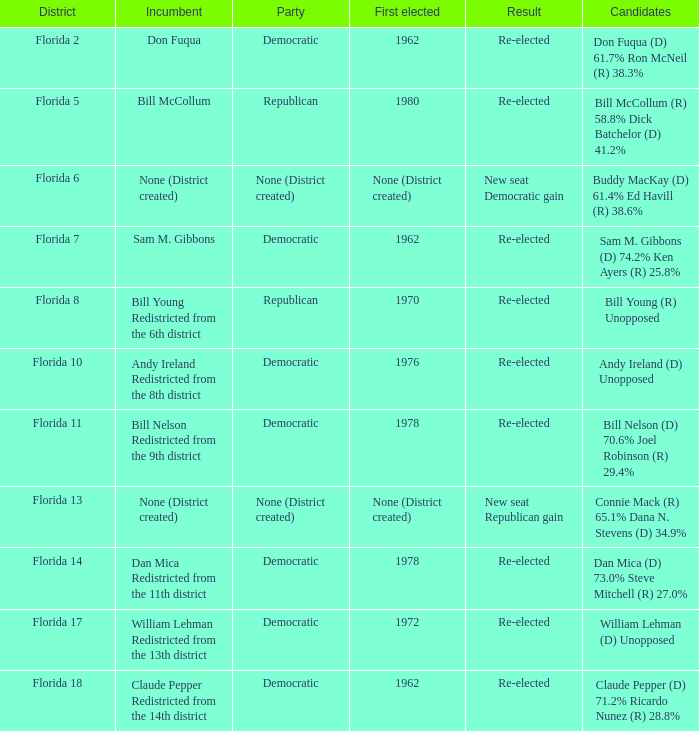What's the district with result being new seat democratic gain Florida 6. 